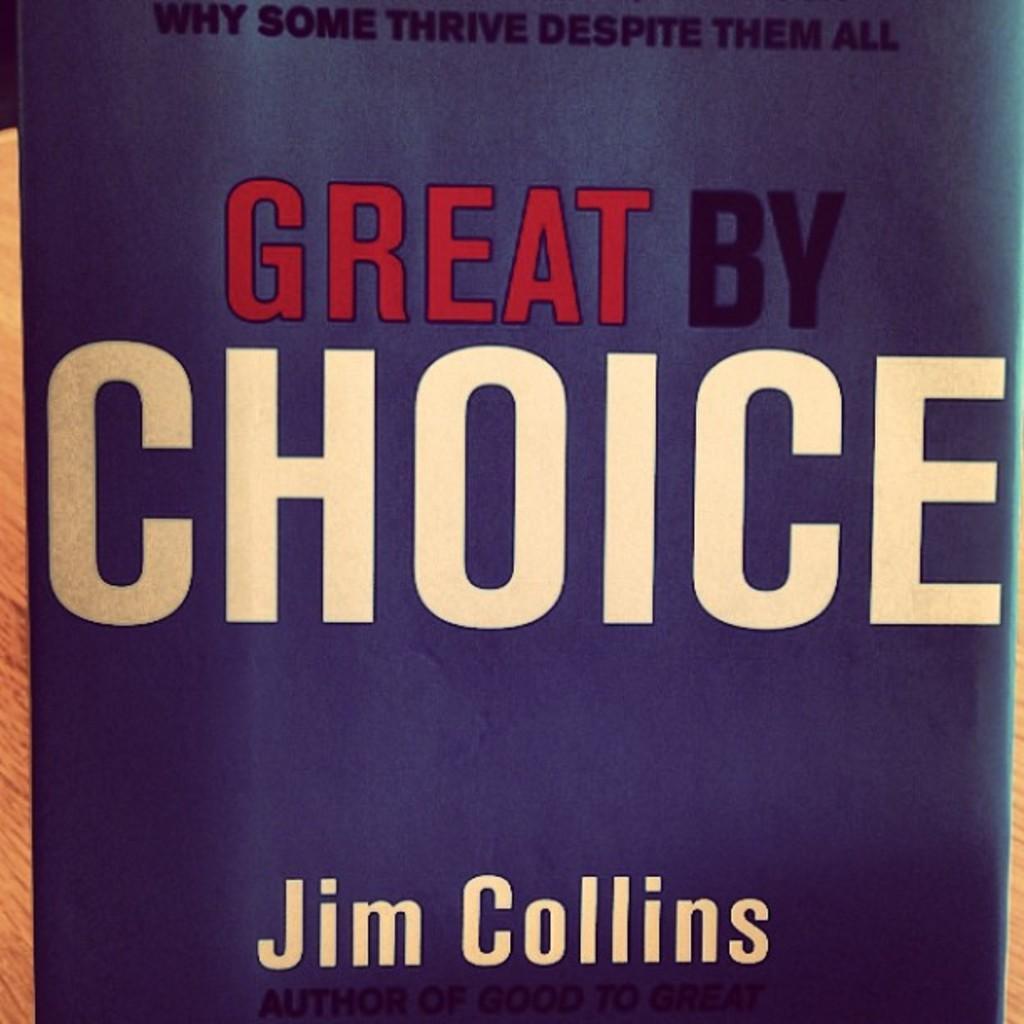In one or two sentences, can you explain what this image depicts? In this image we can see the front page of a book with some text on it. 